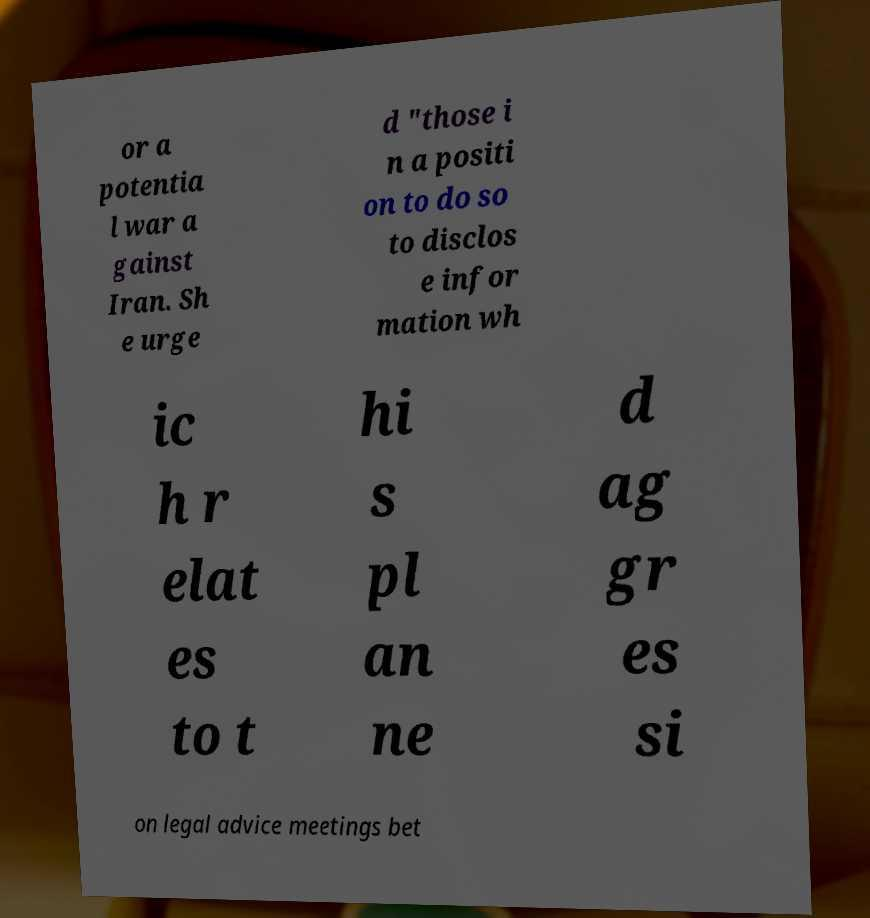Could you assist in decoding the text presented in this image and type it out clearly? or a potentia l war a gainst Iran. Sh e urge d "those i n a positi on to do so to disclos e infor mation wh ic h r elat es to t hi s pl an ne d ag gr es si on legal advice meetings bet 